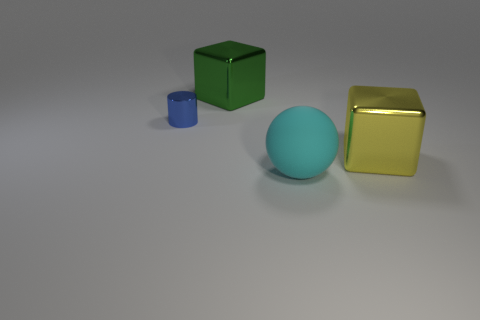Add 2 large gray metal objects. How many objects exist? 6 Subtract 0 brown balls. How many objects are left? 4 Subtract all cylinders. How many objects are left? 3 Subtract 1 cylinders. How many cylinders are left? 0 Subtract all blue balls. Subtract all gray cylinders. How many balls are left? 1 Subtract all yellow spheres. How many gray cubes are left? 0 Subtract all metal blocks. Subtract all small blue metal cylinders. How many objects are left? 1 Add 4 big yellow cubes. How many big yellow cubes are left? 5 Add 4 small yellow matte things. How many small yellow matte things exist? 4 